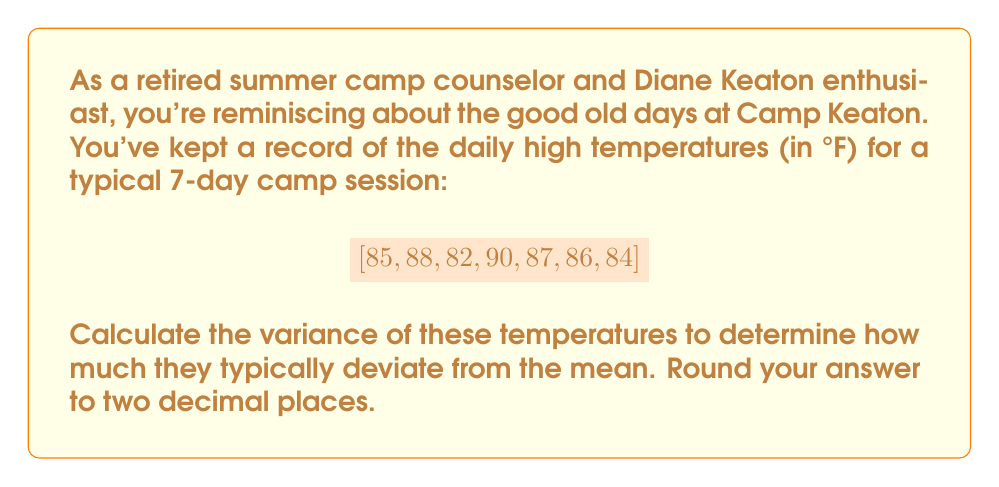Provide a solution to this math problem. Let's approach this step-by-step:

1. First, we need to calculate the mean temperature:
   $\mu = \frac{85 + 88 + 82 + 90 + 87 + 86 + 84}{7} = 86°F$

2. The variance formula is:
   $\sigma^2 = \frac{\sum_{i=1}^{n} (x_i - \mu)^2}{n}$
   where $x_i$ are the individual temperatures and $n$ is the number of days.

3. Let's calculate $(x_i - \mu)^2$ for each temperature:
   $(85 - 86)^2 = (-1)^2 = 1$
   $(88 - 86)^2 = (2)^2 = 4$
   $(82 - 86)^2 = (-4)^2 = 16$
   $(90 - 86)^2 = (4)^2 = 16$
   $(87 - 86)^2 = (1)^2 = 1$
   $(86 - 86)^2 = (0)^2 = 0$
   $(84 - 86)^2 = (-2)^2 = 4$

4. Sum these values:
   $\sum_{i=1}^{n} (x_i - \mu)^2 = 1 + 4 + 16 + 16 + 1 + 0 + 4 = 42$

5. Divide by $n = 7$:
   $\sigma^2 = \frac{42}{7} = 6$

6. Rounding to two decimal places:
   $\sigma^2 = 6.00$
Answer: $6.00°F^2$ 